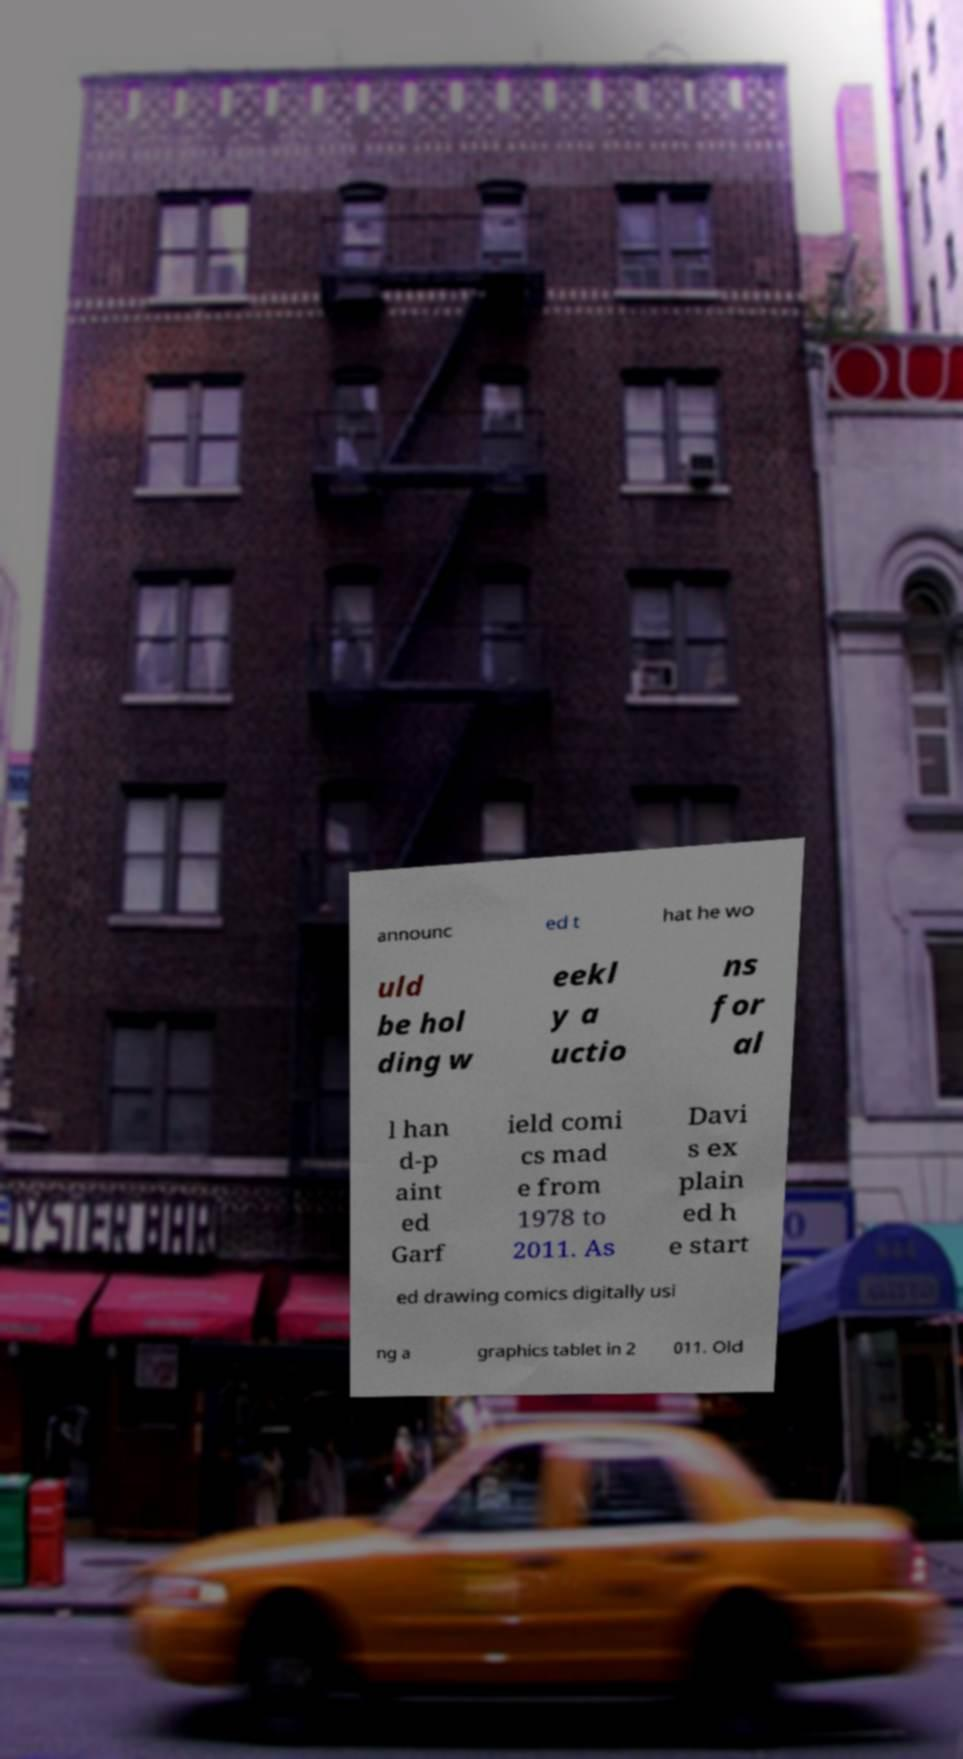Please identify and transcribe the text found in this image. announc ed t hat he wo uld be hol ding w eekl y a uctio ns for al l han d-p aint ed Garf ield comi cs mad e from 1978 to 2011. As Davi s ex plain ed h e start ed drawing comics digitally usi ng a graphics tablet in 2 011. Old 